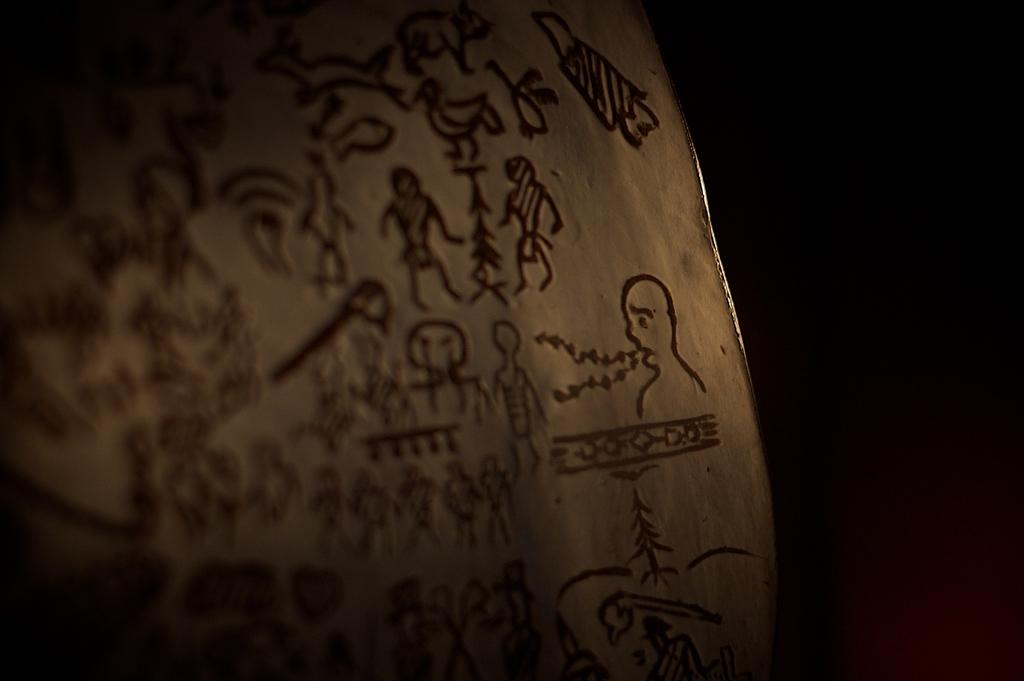What is the main subject of the image? There is an object with some art in the image. Can you describe the background of the image? The background of the image is dark. What type of bridge can be seen in the image? There is no bridge present in the image. What is the object with art used for in the image? The provided facts do not specify the purpose or use of the object with art in the image. 